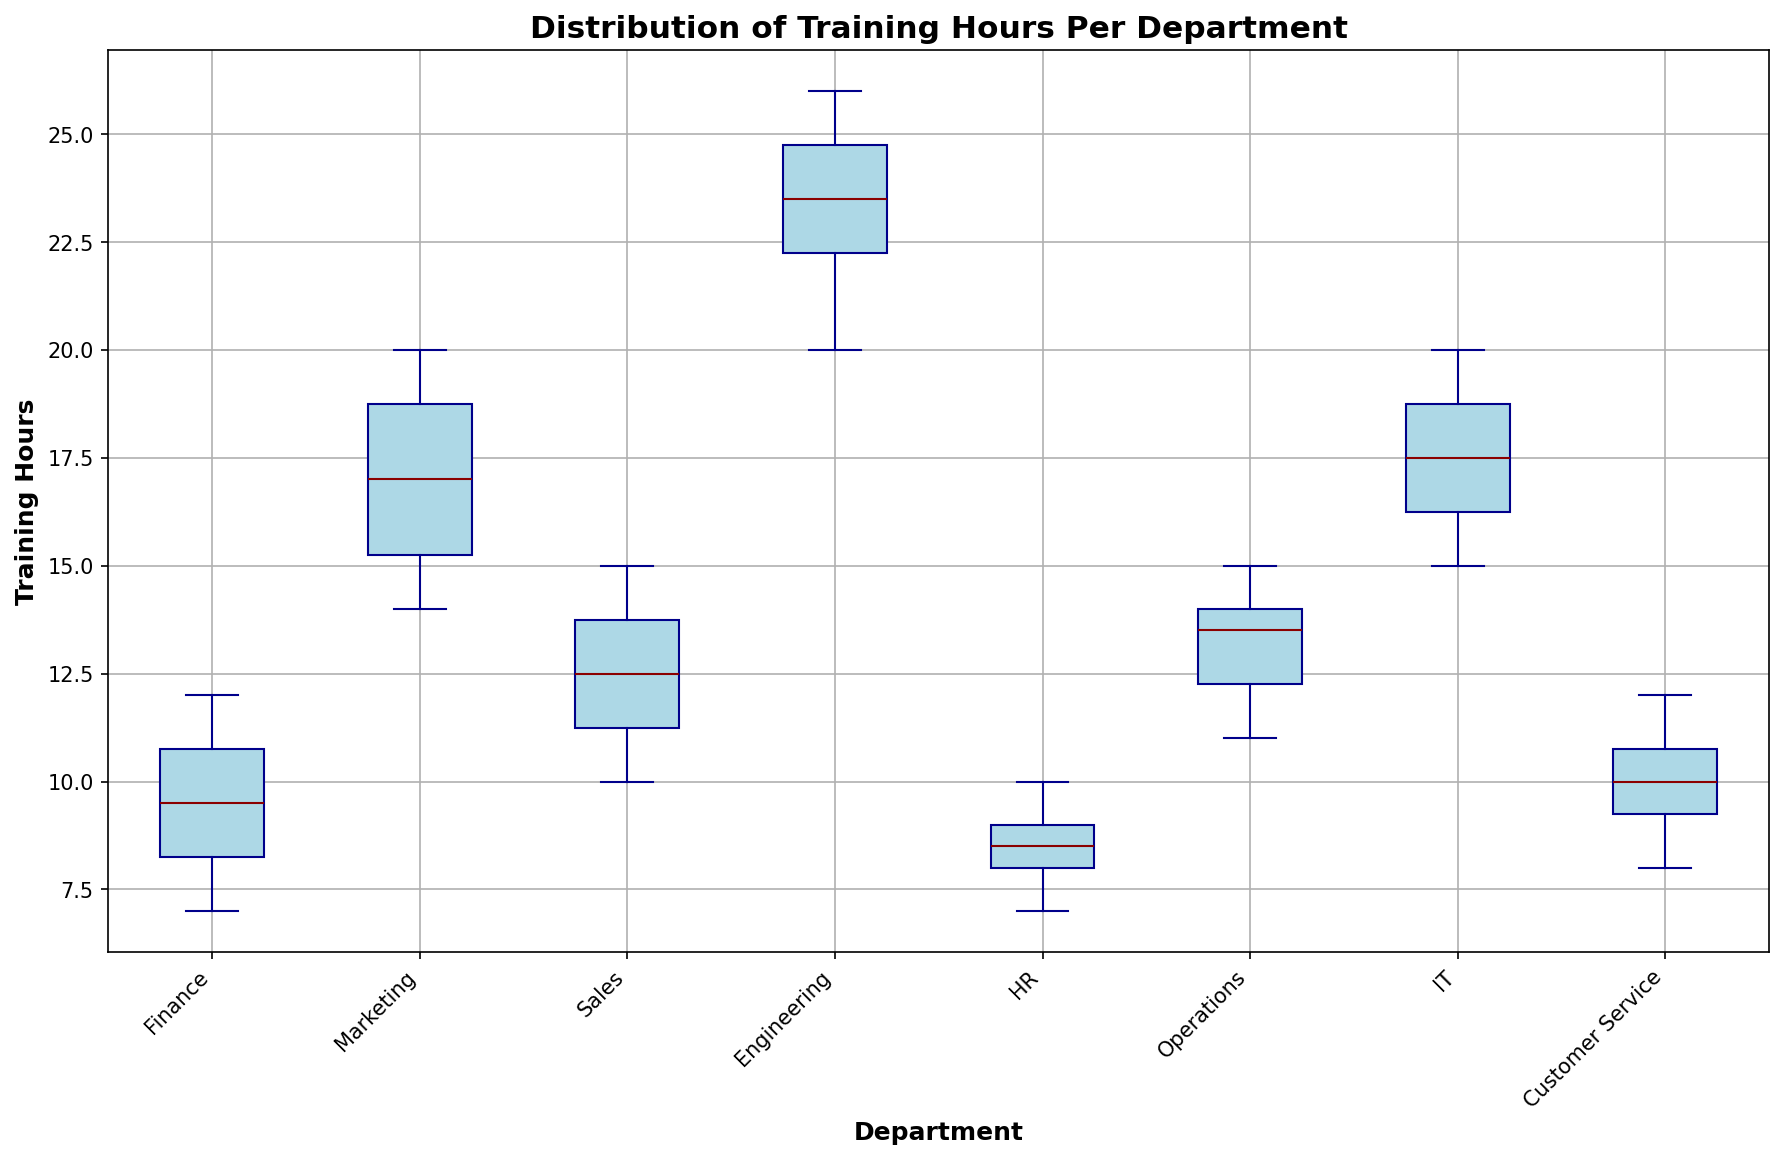What is the median training hours for the Marketing department? The box plot shows the median training hours as the thick horizontal line within the box for each department. For the Marketing department, this line stands at 18 hours.
Answer: 18 Which department has the highest range of training hours? The range of training hours is the difference between the maximum and minimum values (whiskers). The Engineering department has the whiskers extending from 20 to 26 hours, giving the highest range of 6 hours.
Answer: Engineering What is the interquartile range (IQR) of training hours for the Operations department? The IQR is the difference between the third quartile (top of the box) and the first quartile (bottom of the box). For the Operations department, the box extends from 12 hours to 14 hours, giving an IQR of 2 hours.
Answer: 2 Which department has the lowest median training hours? To find the department with the lowest median training hours, look for the shortest thick horizontal line within the boxes. The HR department has its median line at 8 hours, which is the lowest value among all departments.
Answer: HR Are Sales and Customer Service departments having the same median training hours? To check if the medians are the same, compare the positions of the thick horizontal lines within the boxes for both departments. Both Sales and Customer Service have their median lines at 11 hours.
Answer: Yes Describe the spread of the training hours for the Finance department. The box plot displays the distribution with the interquartile range (box), median (thick line within the box), and range (whiskers). For the Finance department, the whiskers extend from 7 to 12 hours, the box from 8 to 11 hours, and the median at 10 hours.
Answer: 7 to 12 hours, median at 10 Which department has training hour outliers, if any? Outliers are represented as points outside the whiskers. There are no outliers visible in the box plot for any of the departments.
Answer: None Compare the median training hours of Engineering and IT departments. To compare, look at the thick horizontal lines within the boxes. Engineering has its median at 23 hours, while IT has it at 18 hours. Therefore, Engineering has a higher median training hour.
Answer: Engineering What is the difference between the maximum training hours of Finance and IT departments? The maximum training hours are indicated by the upper whisker ends. For Finance, it is 12 hours, and for IT, it is 20 hours. The difference is 20 - 12 = 8 hours.
Answer: 8 